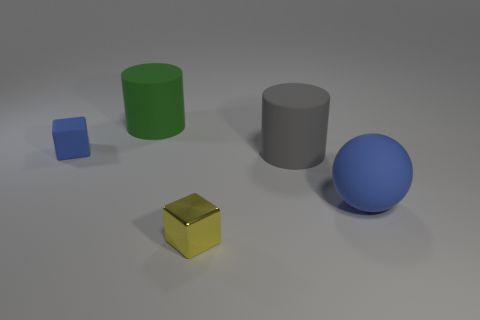Subtract all gray cylinders. How many cylinders are left? 1 Subtract all gray spheres. How many blue cubes are left? 1 Add 3 tiny things. How many tiny things exist? 5 Add 4 brown rubber spheres. How many objects exist? 9 Subtract 0 purple cubes. How many objects are left? 5 Subtract all balls. How many objects are left? 4 Subtract 1 cylinders. How many cylinders are left? 1 Subtract all blue cubes. Subtract all green balls. How many cubes are left? 1 Subtract all small blue matte cubes. Subtract all big balls. How many objects are left? 3 Add 2 big objects. How many big objects are left? 5 